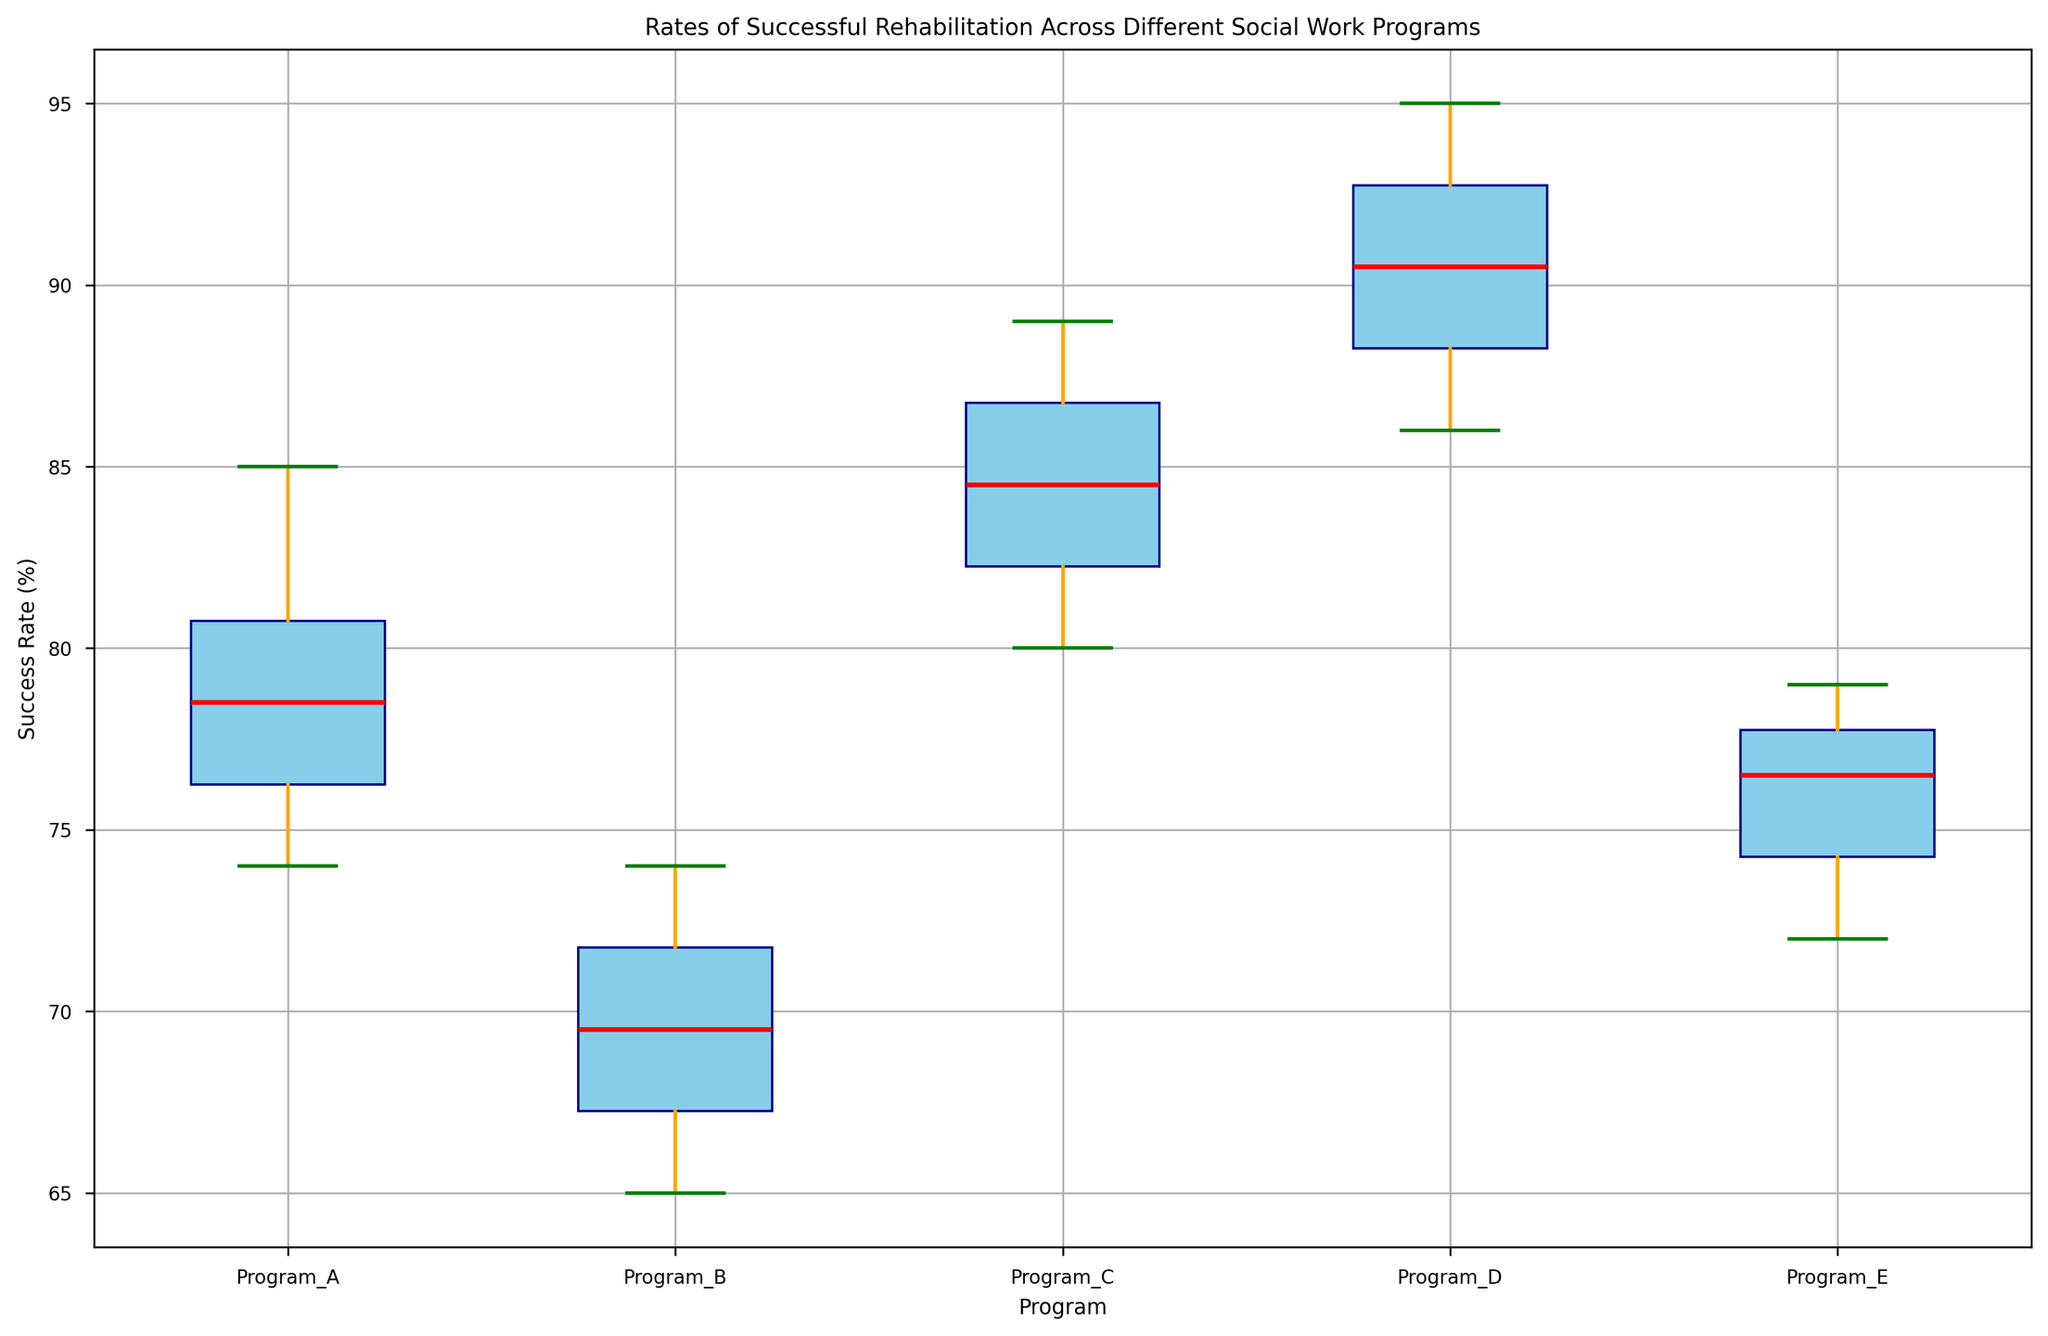Which program has the highest median success rate? The median success rate is indicated by the red lines in the box plot. By comparing the red lines across all programs, Program D has the highest median success rate.
Answer: Program D Which program has the largest spread in success rates? The spread in success rates is the distance between the whiskers. Program B has the largest spread in success rates, as its whiskers span the largest range on the scale.
Answer: Program B What is the interquartile range (IQR) of Program A? The IQR is the height of the box, which represents the middle 50% of the data. For Program A, the lower quartile (Q1) is at 76, and the upper quartile (Q3) is at 81. The IQR is Q3 - Q1 = 81 - 76.
Answer: 5 Which program has the lowest minimum success rate? The minimum success rate is indicated by the lower whisker of each box plot. By comparing the positions of the lower whiskers, Program B has the lowest minimum success rate.
Answer: Program B How does the median success rate of Program E compare to Program A? The median success rate is indicated by the red line within each box. Comparing the positions of the red lines, the median success rate of Program E is slightly lower than that of Program A.
Answer: Lower What is the range of success rates for Program C? The range is the difference between the highest and lowest data points. For Program C, the highest value is 89, and the lowest value is 80. Therefore, the range is 89 - 80.
Answer: 9 Which program has no outliers in the success rates? Outliers are represented by individual points outside the whiskers. By examining the box plots, Programs B and D have no outliers.
Answer: Programs B and D What is the median success rate for Program C? The median success rate is marked by the red line within the box. For Program C, it is approximately 85.
Answer: 85 Does Program A or Program E have a higher variance in success rates? Variance can be inferred from the overall spread of the data. Both the range and IQR can be indicators. Program A's IQR and overall spread are slightly larger compared to Program E, indicating a higher variance.
Answer: Program A How does the upper quartile (Q3) value for Program D compare to Program B? The upper quartile (Q3) is the top line of the box. For Program D, Q3 is around 93, while for Program B, Q3 is around 73. Thus, Program D's Q3 is significantly higher than that of Program B.
Answer: Much higher 